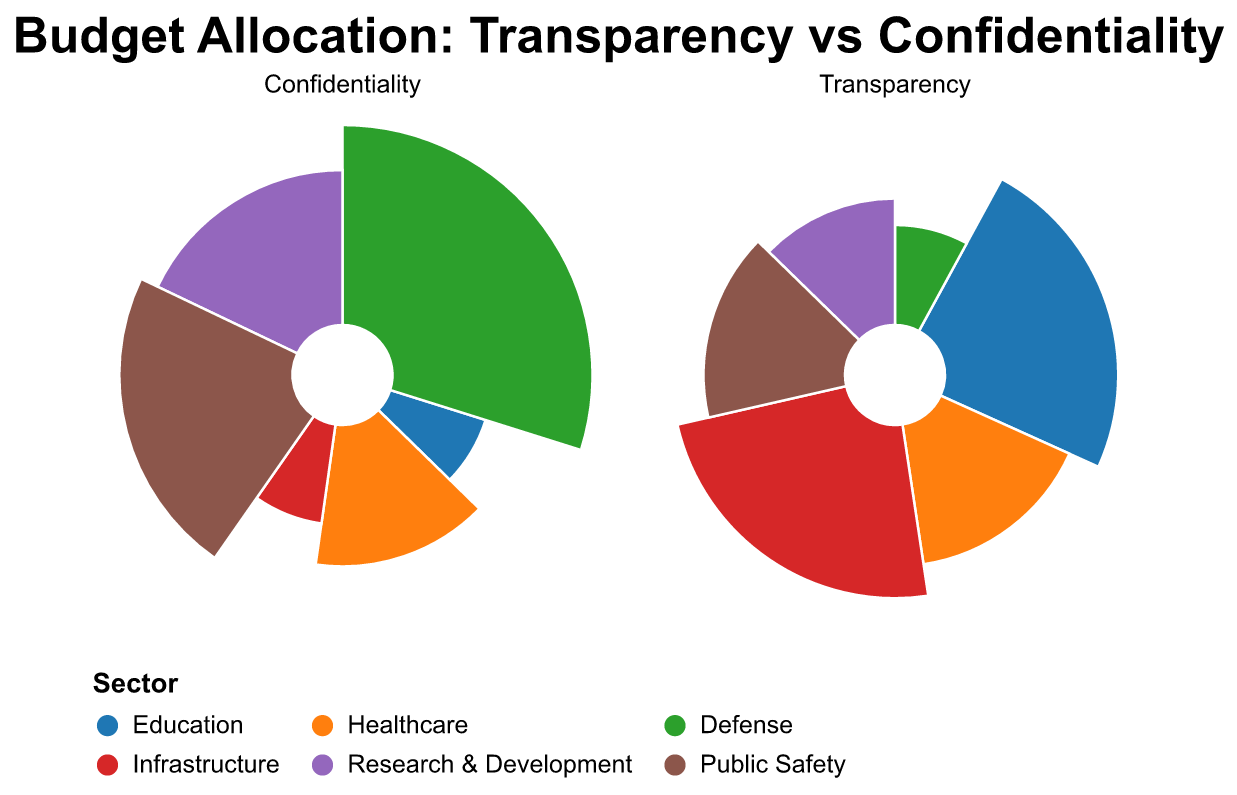What is the title of the figure? The title is prominently displayed at the top center of the figure. It reads "Budget Allocation: Transparency vs Confidentiality".
Answer: Budget Allocation: Transparency vs Confidentiality Which sector has the highest allocation under Confidentiality? By visually inspecting the subplot corresponding to Confidentiality, the sector with the largest segment is Defense, indicating it has the highest allocation.
Answer: Defense How does the allocation to Education differ between Transparency and Confidentiality? The Transparency subplot shows Education with an allocation of 15, while the Confidentiality subplot shows Education with an allocation of 5, indicating a higher allocation in Transparency.
Answer: Education has 10 more under Transparency What is the total allocation to Healthcare? Healthcare has values of 10 under both Transparency and Confidentiality. Adding these together, the total allocation is 10 + 10 = 20.
Answer: 20 Which sector is equally allocated between Transparency and Confidentiality? By comparing both subplots, Healthcare is the only sector with equal allocations of 10 in both Transparency and Confidentiality.
Answer: Healthcare What is the combined allocation to Research & Development and Public Safety under Transparency? The values for Research & Development and Public Safety under Transparency are 8 and 10 respectively. Adding these gives 8 + 10 = 18.
Answer: 18 Which sector has the largest difference in allocation between Transparency and Confidentiality? By calculating the differences, Defense shows a Transparency value of 5 and a Confidentiality value of 20, resulting in the largest difference of 15.
Answer: Defense What are the colors used to represent Education and Infrastructure sectors? Education is represented in blue and Infrastructure is represented in red. These colors are visibly distinguishable in the legend and the allocated segments.
Answer: Blue and Red 